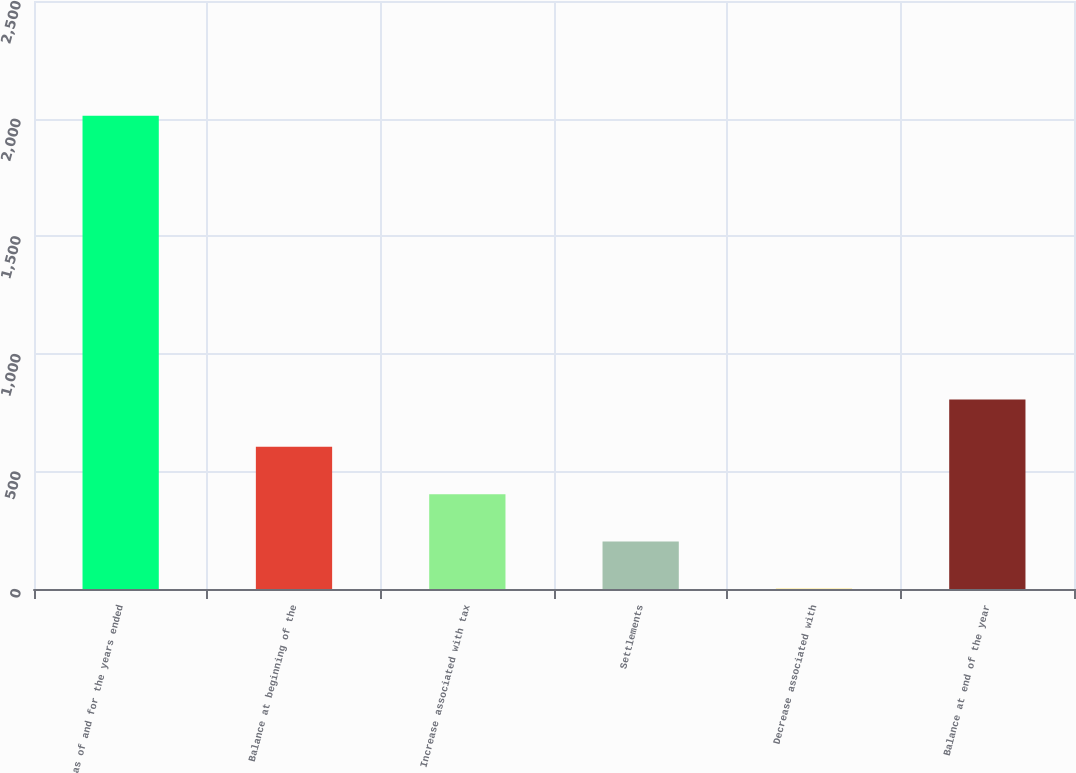Convert chart. <chart><loc_0><loc_0><loc_500><loc_500><bar_chart><fcel>as of and for the years ended<fcel>Balance at beginning of the<fcel>Increase associated with tax<fcel>Settlements<fcel>Decrease associated with<fcel>Balance at end of the year<nl><fcel>2012<fcel>604.3<fcel>403.2<fcel>202.1<fcel>1<fcel>805.4<nl></chart> 